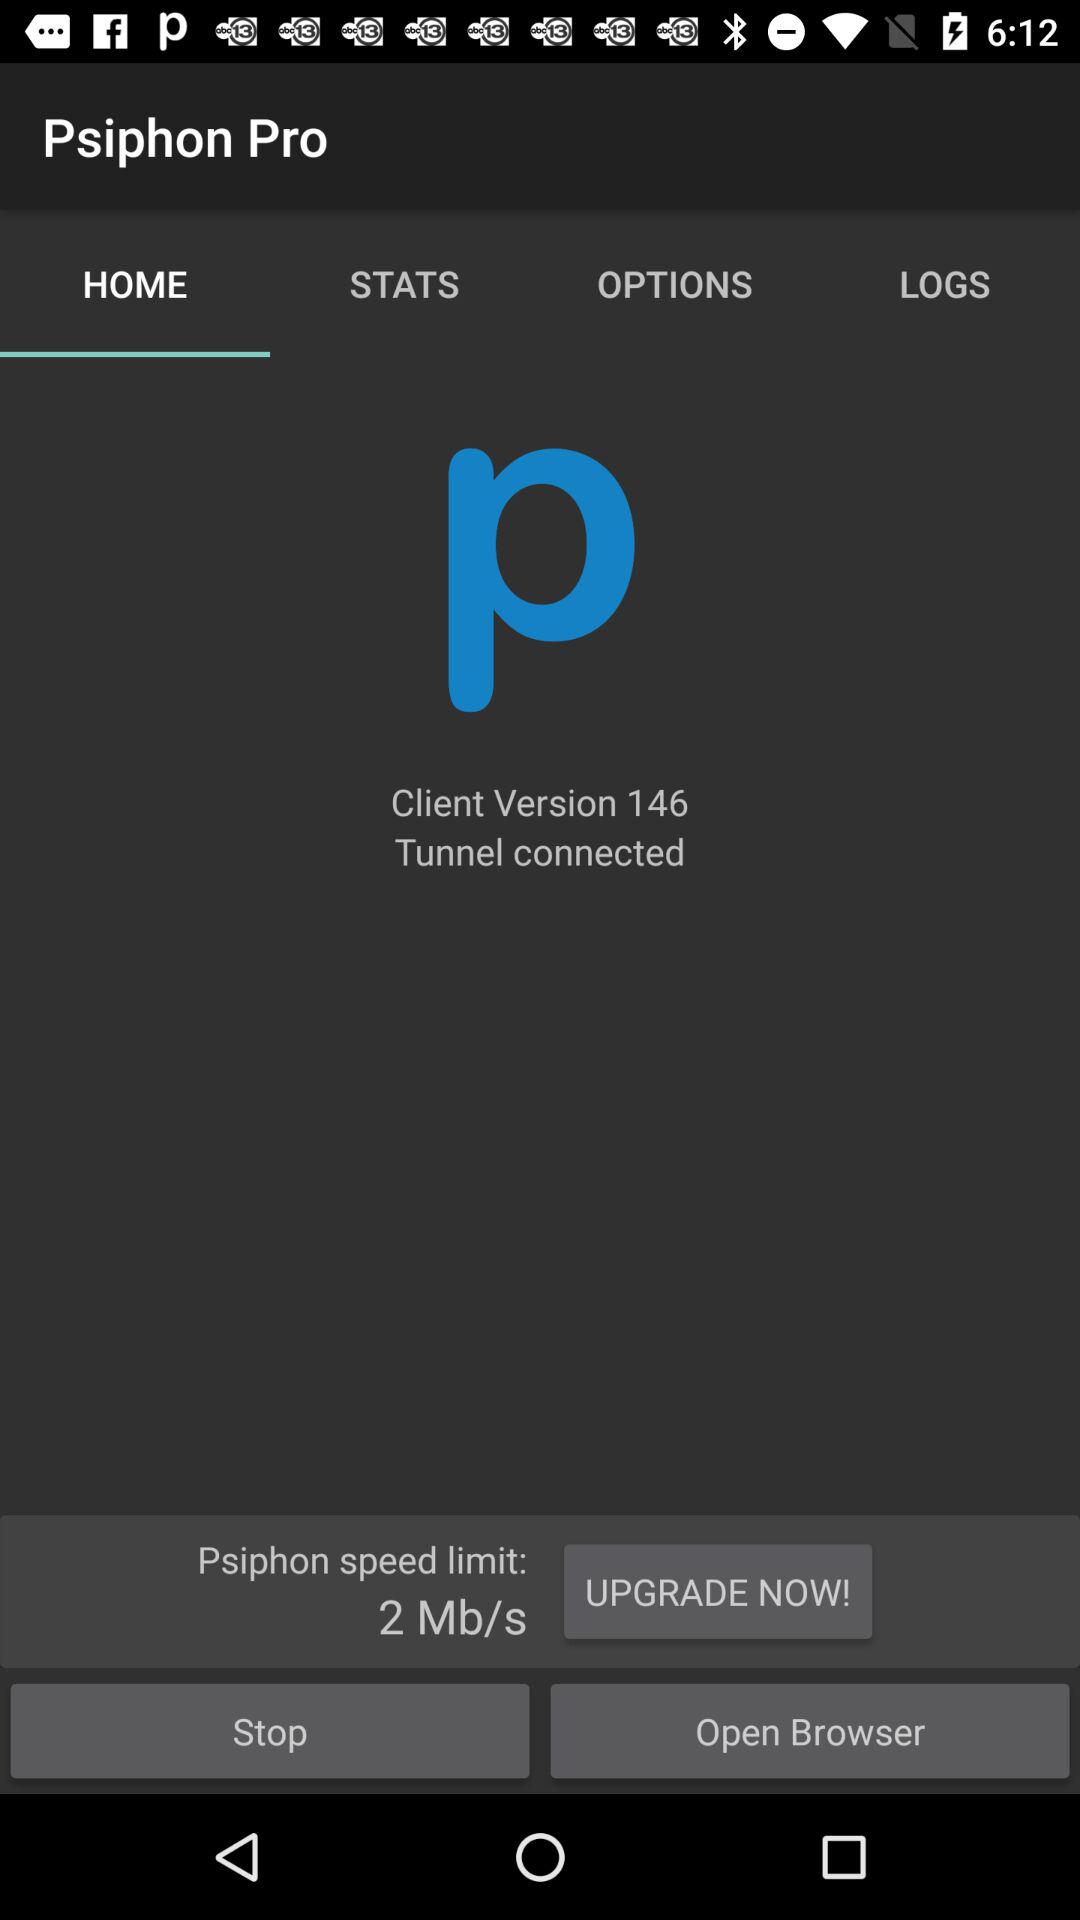What tab am I on? You are on the "HOME" tab. 